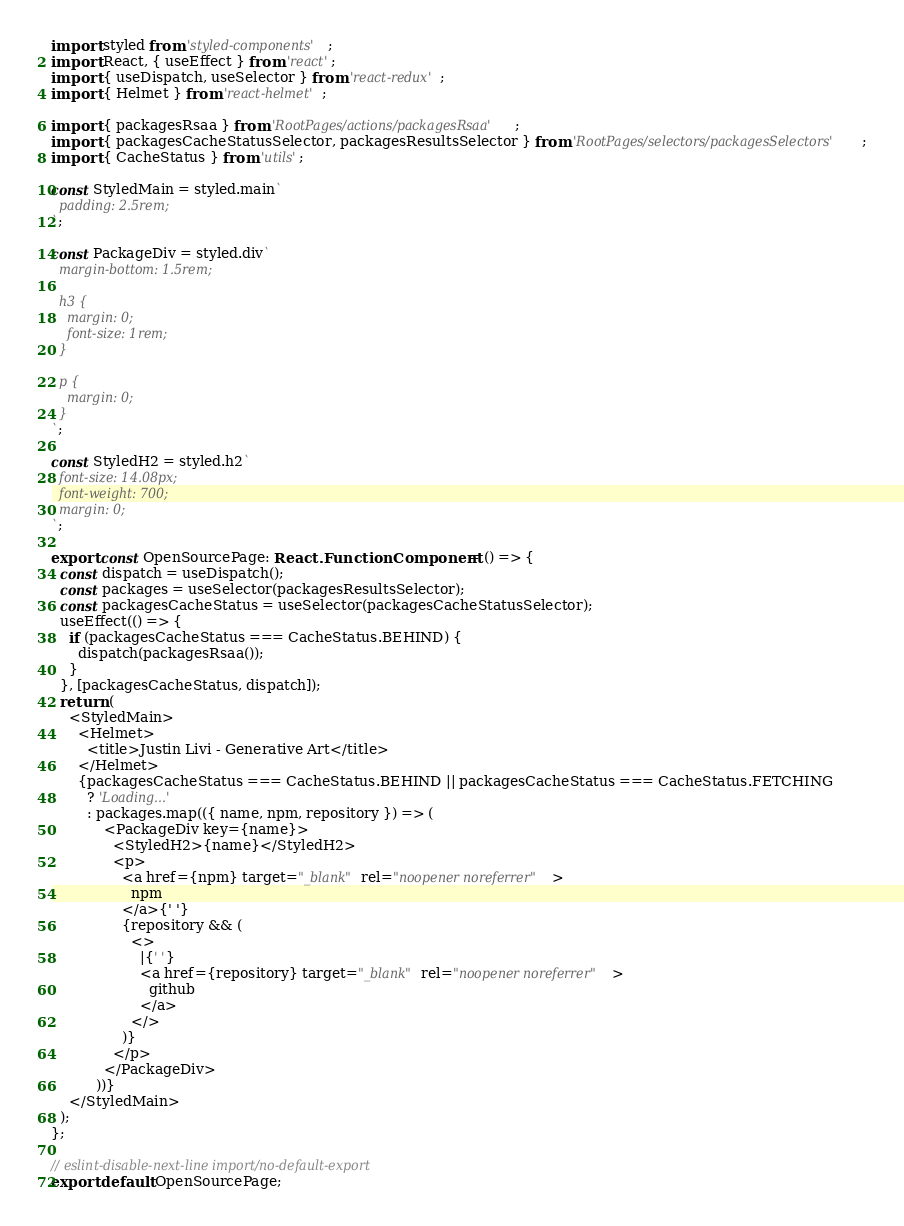<code> <loc_0><loc_0><loc_500><loc_500><_TypeScript_>import styled from 'styled-components';
import React, { useEffect } from 'react';
import { useDispatch, useSelector } from 'react-redux';
import { Helmet } from 'react-helmet';

import { packagesRsaa } from 'RootPages/actions/packagesRsaa';
import { packagesCacheStatusSelector, packagesResultsSelector } from 'RootPages/selectors/packagesSelectors';
import { CacheStatus } from 'utils';

const StyledMain = styled.main`
  padding: 2.5rem;
`;

const PackageDiv = styled.div`
  margin-bottom: 1.5rem;

  h3 {
    margin: 0;
    font-size: 1rem;
  }

  p {
    margin: 0;
  }
`;

const StyledH2 = styled.h2`
  font-size: 14.08px;
  font-weight: 700;
  margin: 0;
`;

export const OpenSourcePage: React.FunctionComponent = () => {
  const dispatch = useDispatch();
  const packages = useSelector(packagesResultsSelector);
  const packagesCacheStatus = useSelector(packagesCacheStatusSelector);
  useEffect(() => {
    if (packagesCacheStatus === CacheStatus.BEHIND) {
      dispatch(packagesRsaa());
    }
  }, [packagesCacheStatus, dispatch]);
  return (
    <StyledMain>
      <Helmet>
        <title>Justin Livi - Generative Art</title>
      </Helmet>
      {packagesCacheStatus === CacheStatus.BEHIND || packagesCacheStatus === CacheStatus.FETCHING
        ? 'Loading...'
        : packages.map(({ name, npm, repository }) => (
            <PackageDiv key={name}>
              <StyledH2>{name}</StyledH2>
              <p>
                <a href={npm} target="_blank" rel="noopener noreferrer">
                  npm
                </a>{' '}
                {repository && (
                  <>
                    |{' '}
                    <a href={repository} target="_blank" rel="noopener noreferrer">
                      github
                    </a>
                  </>
                )}
              </p>
            </PackageDiv>
          ))}
    </StyledMain>
  );
};

// eslint-disable-next-line import/no-default-export
export default OpenSourcePage;
</code> 